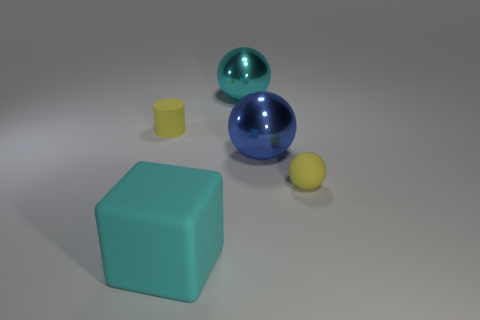There is a yellow object that is the same shape as the big blue object; what is its material? Considering the image, the yellow object resembling the shape of the larger blue object appears to be made of plastic. Both objects share a spherical characteristic indicative of a smooth, non-porous material with a matte finish characteristic of many plastic items. 